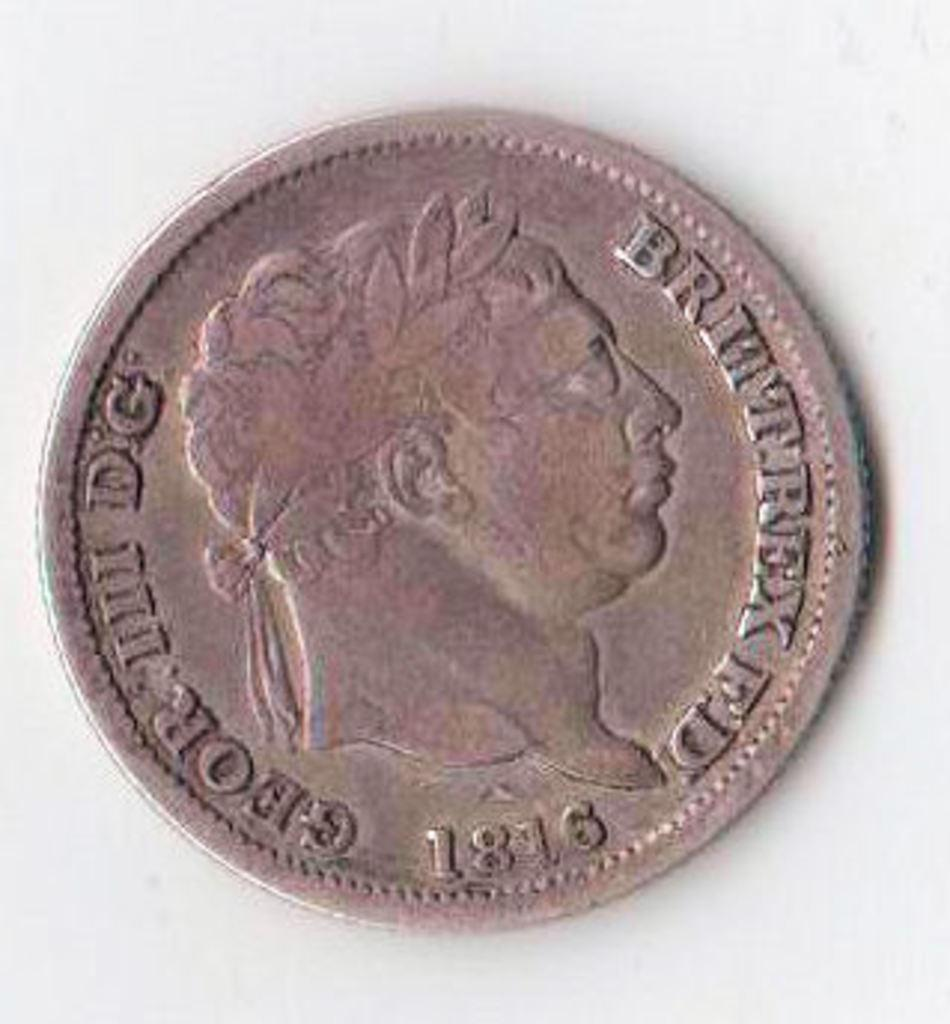<image>
Present a compact description of the photo's key features. An old coin reads Brittrex FD 1816 and has a picture of a man on it. 